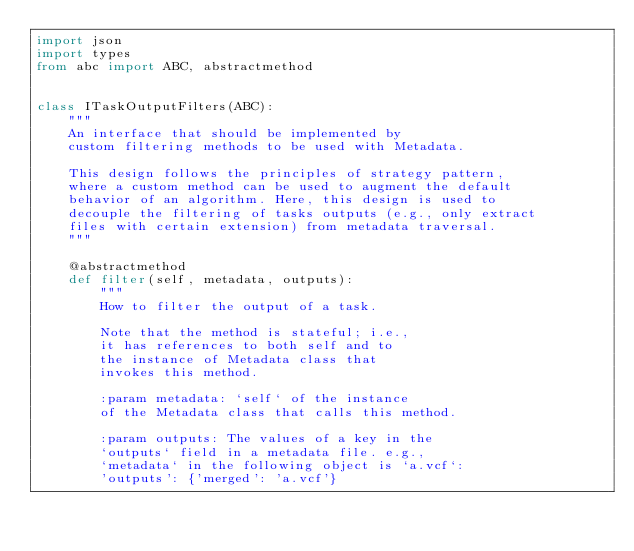Convert code to text. <code><loc_0><loc_0><loc_500><loc_500><_Python_>import json
import types
from abc import ABC, abstractmethod


class ITaskOutputFilters(ABC):
    """
    An interface that should be implemented by
    custom filtering methods to be used with Metadata.

    This design follows the principles of strategy pattern,
    where a custom method can be used to augment the default
    behavior of an algorithm. Here, this design is used to
    decouple the filtering of tasks outputs (e.g., only extract
    files with certain extension) from metadata traversal.
    """

    @abstractmethod
    def filter(self, metadata, outputs):
        """
        How to filter the output of a task.

        Note that the method is stateful; i.e.,
        it has references to both self and to
        the instance of Metadata class that
        invokes this method.

        :param metadata: `self` of the instance
        of the Metadata class that calls this method.

        :param outputs: The values of a key in the
        `outputs` field in a metadata file. e.g.,
        `metadata` in the following object is `a.vcf`:
        'outputs': {'merged': 'a.vcf'}
</code> 